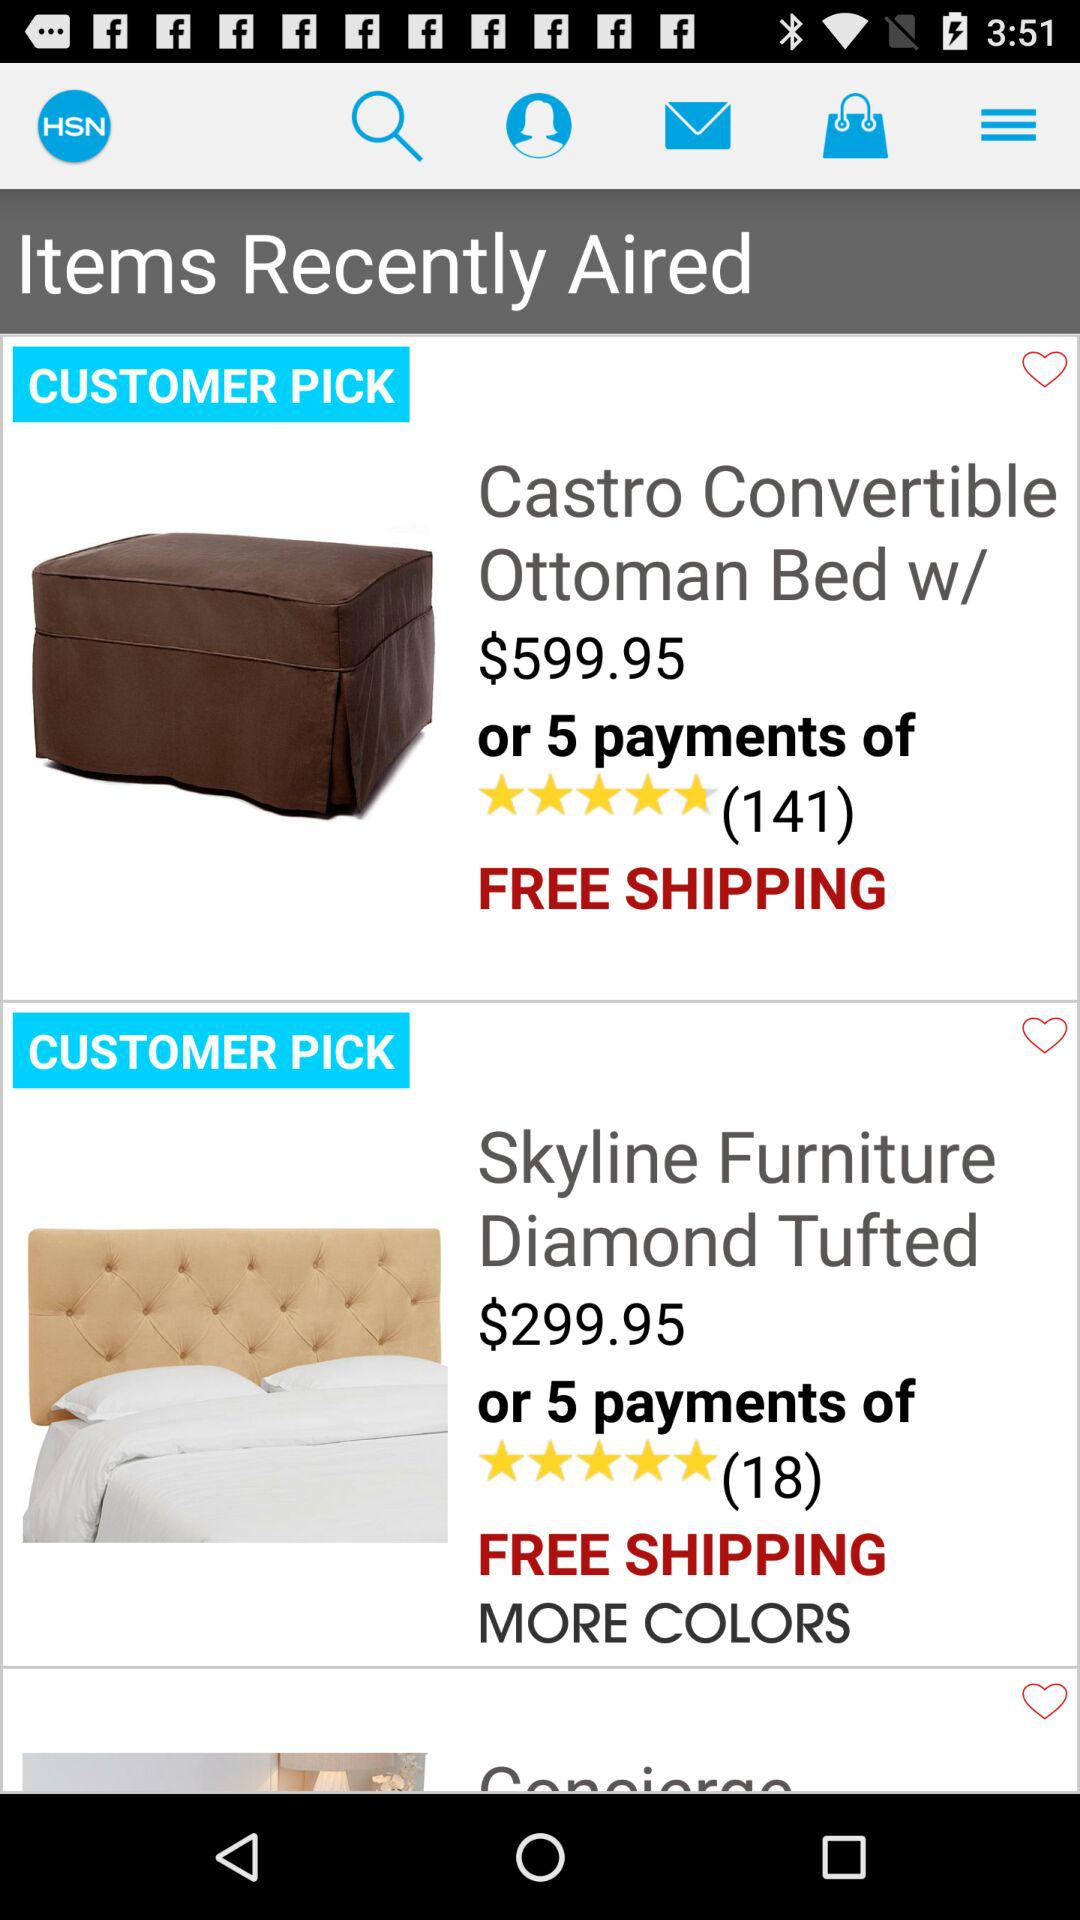What is the rating of "Castro Convertible Ottoman Bed w/"? The rating is 5 stars. 